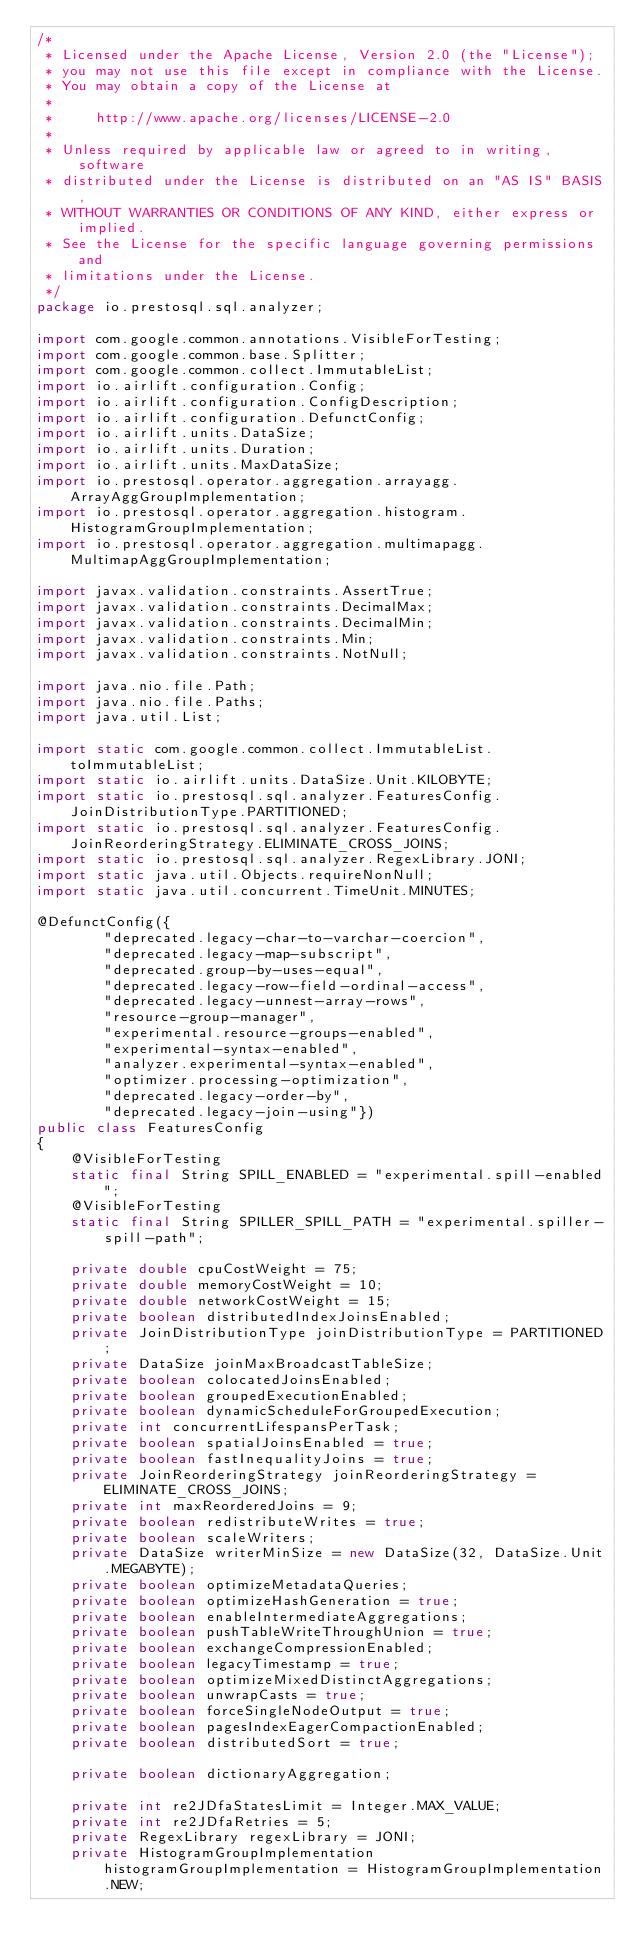Convert code to text. <code><loc_0><loc_0><loc_500><loc_500><_Java_>/*
 * Licensed under the Apache License, Version 2.0 (the "License");
 * you may not use this file except in compliance with the License.
 * You may obtain a copy of the License at
 *
 *     http://www.apache.org/licenses/LICENSE-2.0
 *
 * Unless required by applicable law or agreed to in writing, software
 * distributed under the License is distributed on an "AS IS" BASIS,
 * WITHOUT WARRANTIES OR CONDITIONS OF ANY KIND, either express or implied.
 * See the License for the specific language governing permissions and
 * limitations under the License.
 */
package io.prestosql.sql.analyzer;

import com.google.common.annotations.VisibleForTesting;
import com.google.common.base.Splitter;
import com.google.common.collect.ImmutableList;
import io.airlift.configuration.Config;
import io.airlift.configuration.ConfigDescription;
import io.airlift.configuration.DefunctConfig;
import io.airlift.units.DataSize;
import io.airlift.units.Duration;
import io.airlift.units.MaxDataSize;
import io.prestosql.operator.aggregation.arrayagg.ArrayAggGroupImplementation;
import io.prestosql.operator.aggregation.histogram.HistogramGroupImplementation;
import io.prestosql.operator.aggregation.multimapagg.MultimapAggGroupImplementation;

import javax.validation.constraints.AssertTrue;
import javax.validation.constraints.DecimalMax;
import javax.validation.constraints.DecimalMin;
import javax.validation.constraints.Min;
import javax.validation.constraints.NotNull;

import java.nio.file.Path;
import java.nio.file.Paths;
import java.util.List;

import static com.google.common.collect.ImmutableList.toImmutableList;
import static io.airlift.units.DataSize.Unit.KILOBYTE;
import static io.prestosql.sql.analyzer.FeaturesConfig.JoinDistributionType.PARTITIONED;
import static io.prestosql.sql.analyzer.FeaturesConfig.JoinReorderingStrategy.ELIMINATE_CROSS_JOINS;
import static io.prestosql.sql.analyzer.RegexLibrary.JONI;
import static java.util.Objects.requireNonNull;
import static java.util.concurrent.TimeUnit.MINUTES;

@DefunctConfig({
        "deprecated.legacy-char-to-varchar-coercion",
        "deprecated.legacy-map-subscript",
        "deprecated.group-by-uses-equal",
        "deprecated.legacy-row-field-ordinal-access",
        "deprecated.legacy-unnest-array-rows",
        "resource-group-manager",
        "experimental.resource-groups-enabled",
        "experimental-syntax-enabled",
        "analyzer.experimental-syntax-enabled",
        "optimizer.processing-optimization",
        "deprecated.legacy-order-by",
        "deprecated.legacy-join-using"})
public class FeaturesConfig
{
    @VisibleForTesting
    static final String SPILL_ENABLED = "experimental.spill-enabled";
    @VisibleForTesting
    static final String SPILLER_SPILL_PATH = "experimental.spiller-spill-path";

    private double cpuCostWeight = 75;
    private double memoryCostWeight = 10;
    private double networkCostWeight = 15;
    private boolean distributedIndexJoinsEnabled;
    private JoinDistributionType joinDistributionType = PARTITIONED;
    private DataSize joinMaxBroadcastTableSize;
    private boolean colocatedJoinsEnabled;
    private boolean groupedExecutionEnabled;
    private boolean dynamicScheduleForGroupedExecution;
    private int concurrentLifespansPerTask;
    private boolean spatialJoinsEnabled = true;
    private boolean fastInequalityJoins = true;
    private JoinReorderingStrategy joinReorderingStrategy = ELIMINATE_CROSS_JOINS;
    private int maxReorderedJoins = 9;
    private boolean redistributeWrites = true;
    private boolean scaleWriters;
    private DataSize writerMinSize = new DataSize(32, DataSize.Unit.MEGABYTE);
    private boolean optimizeMetadataQueries;
    private boolean optimizeHashGeneration = true;
    private boolean enableIntermediateAggregations;
    private boolean pushTableWriteThroughUnion = true;
    private boolean exchangeCompressionEnabled;
    private boolean legacyTimestamp = true;
    private boolean optimizeMixedDistinctAggregations;
    private boolean unwrapCasts = true;
    private boolean forceSingleNodeOutput = true;
    private boolean pagesIndexEagerCompactionEnabled;
    private boolean distributedSort = true;

    private boolean dictionaryAggregation;

    private int re2JDfaStatesLimit = Integer.MAX_VALUE;
    private int re2JDfaRetries = 5;
    private RegexLibrary regexLibrary = JONI;
    private HistogramGroupImplementation histogramGroupImplementation = HistogramGroupImplementation.NEW;</code> 